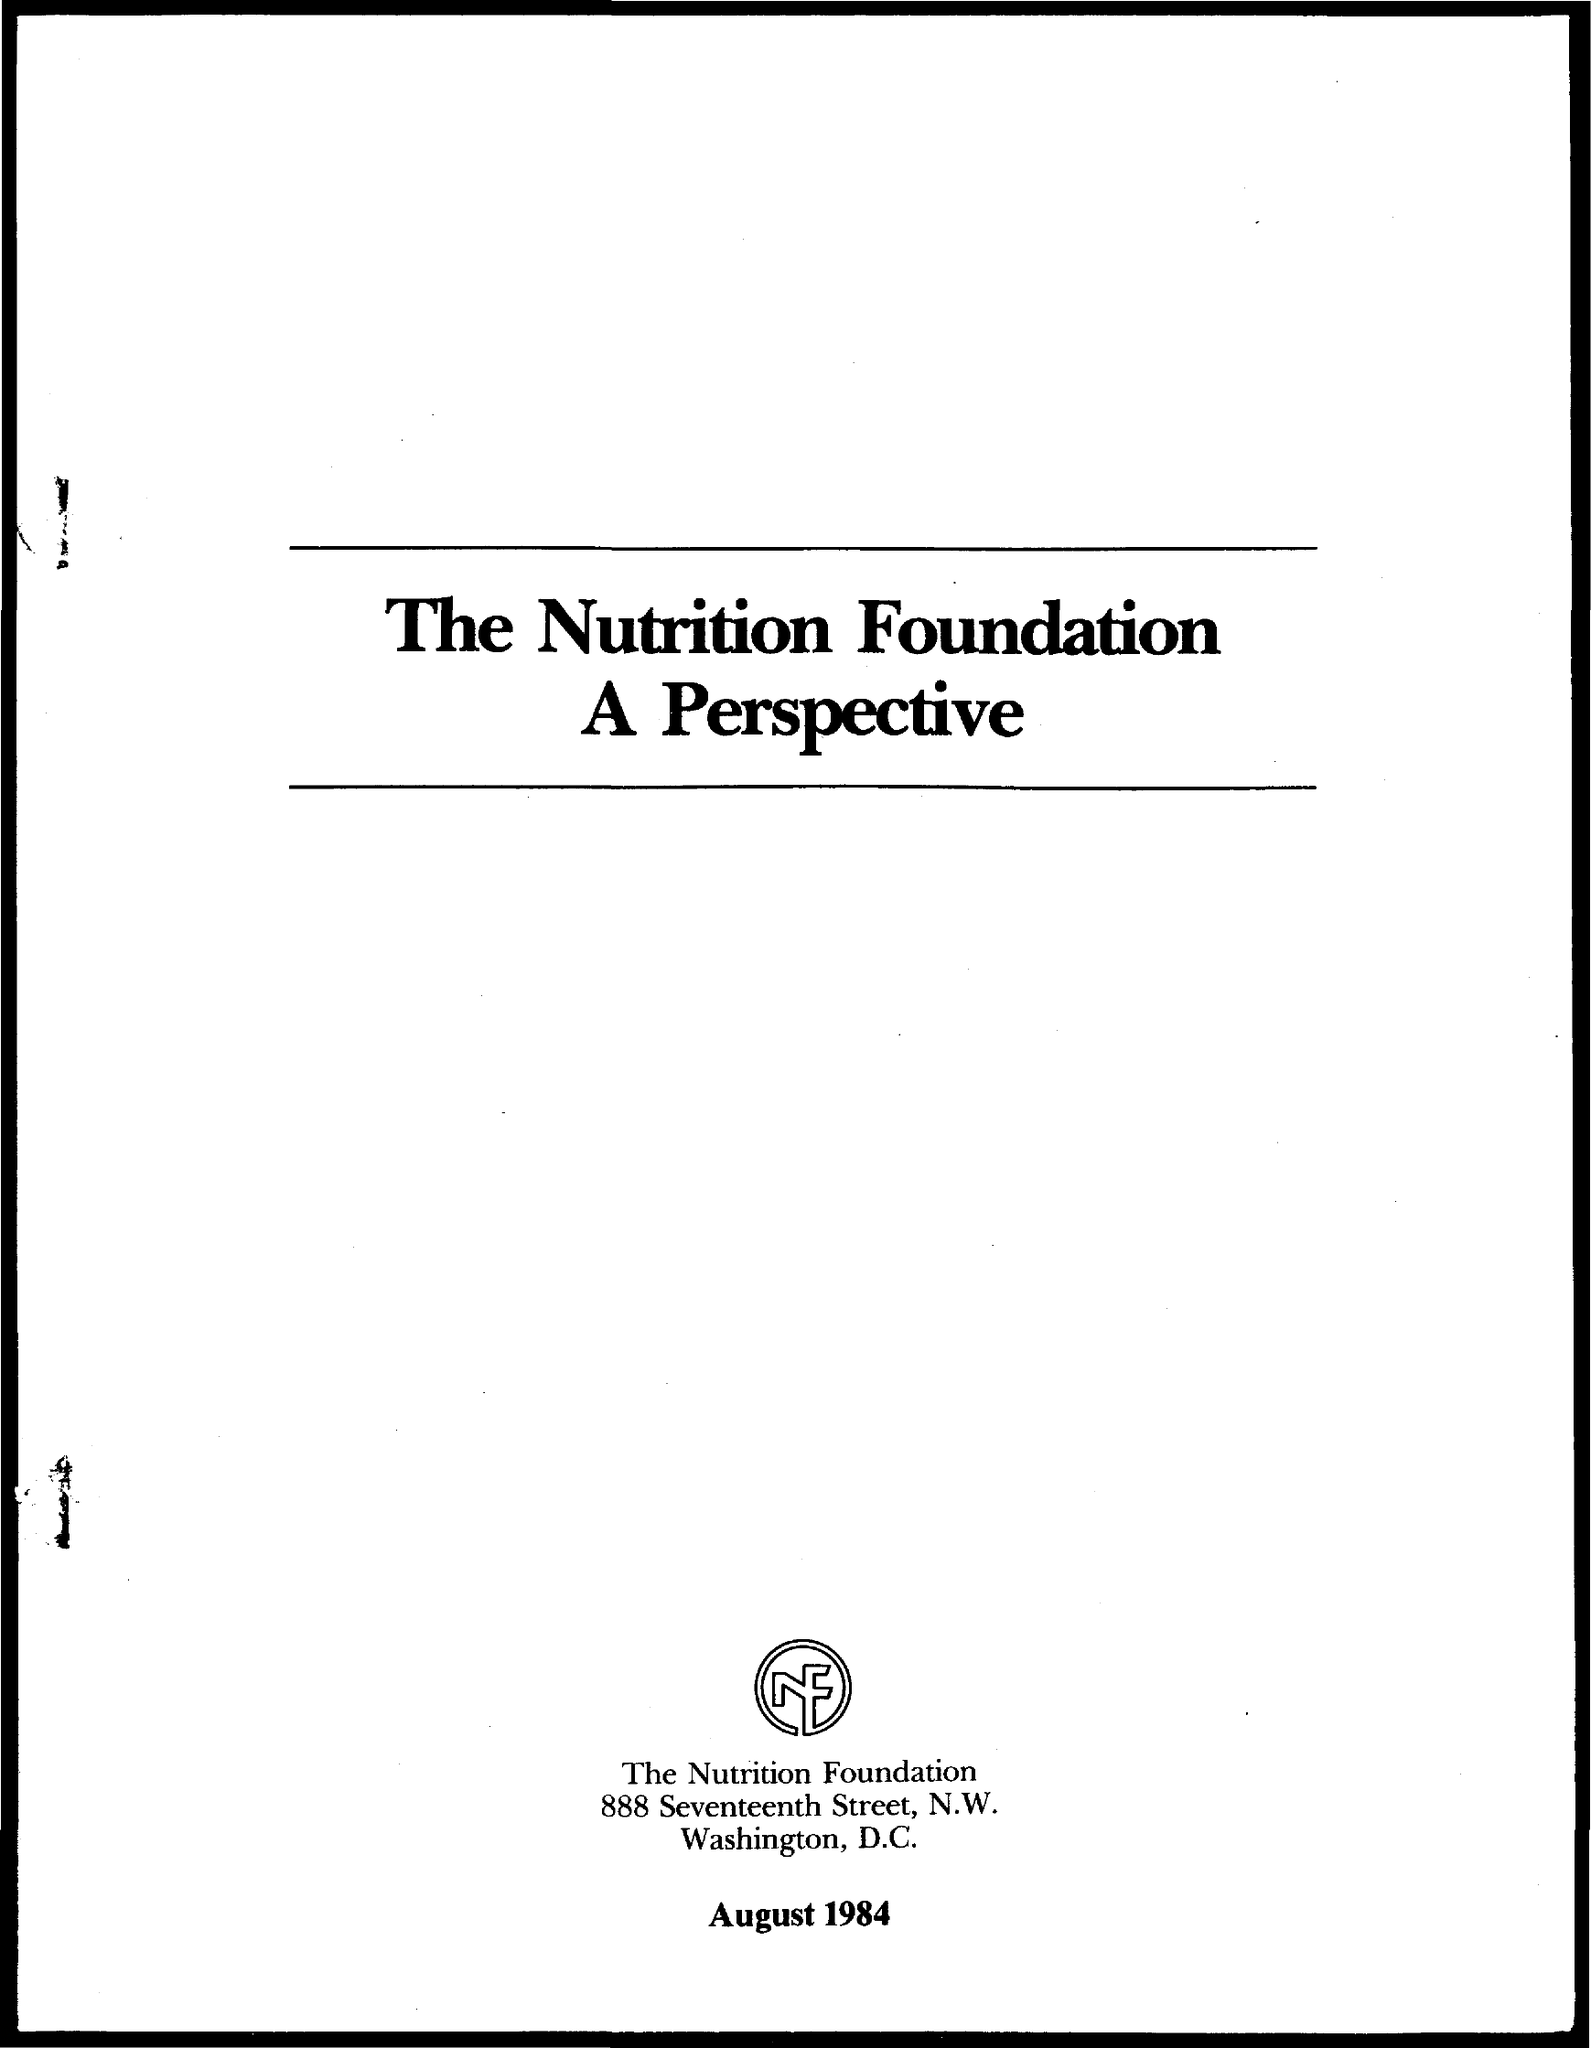What is the date on the document?
Your answer should be very brief. August 1984. 